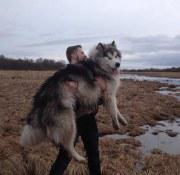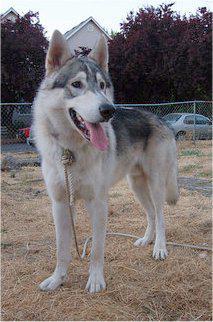The first image is the image on the left, the second image is the image on the right. Assess this claim about the two images: "The left and right image contains the same number of dogs.". Correct or not? Answer yes or no. Yes. The first image is the image on the left, the second image is the image on the right. Assess this claim about the two images: "One image shows a woman standing behind a dog standing in profile turned leftward, and a sign with a prize ribbon is upright on the ground in front of the dog.". Correct or not? Answer yes or no. No. 